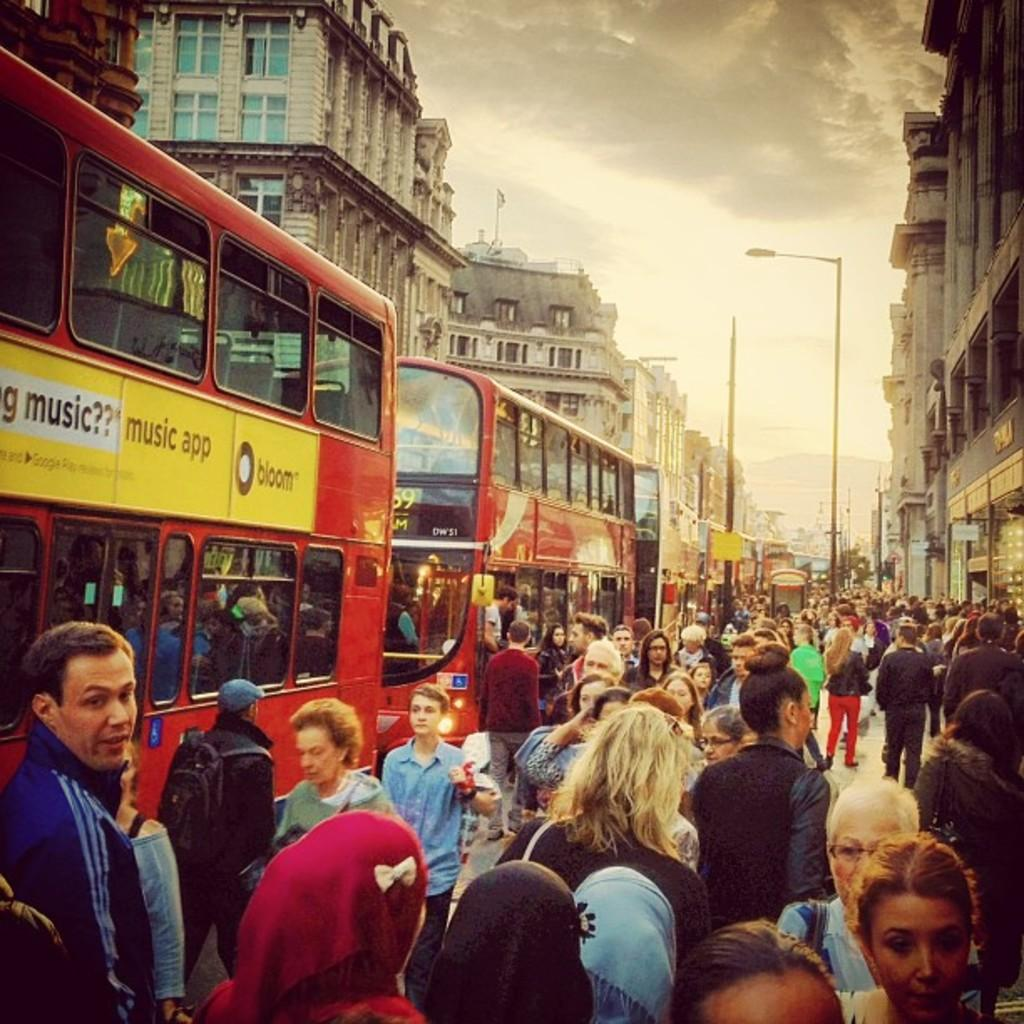<image>
Create a compact narrative representing the image presented. A double decker bus advertises the music app called Bloom. 